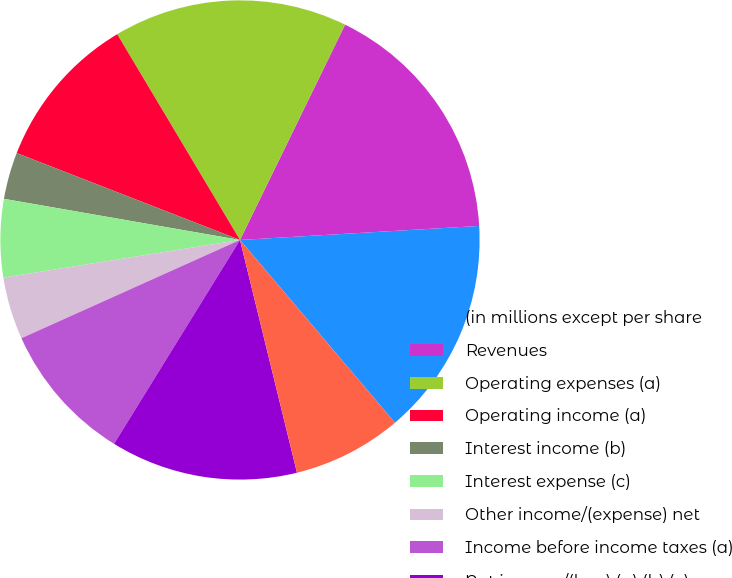Convert chart to OTSL. <chart><loc_0><loc_0><loc_500><loc_500><pie_chart><fcel>(in millions except per share<fcel>Revenues<fcel>Operating expenses (a)<fcel>Operating income (a)<fcel>Interest income (b)<fcel>Interest expense (c)<fcel>Other income/(expense) net<fcel>Income before income taxes (a)<fcel>Net income/(loss) (a) (b) (c)<fcel>Depreciation and amortization<nl><fcel>14.74%<fcel>16.84%<fcel>15.79%<fcel>10.53%<fcel>3.16%<fcel>5.26%<fcel>4.21%<fcel>9.47%<fcel>12.63%<fcel>7.37%<nl></chart> 